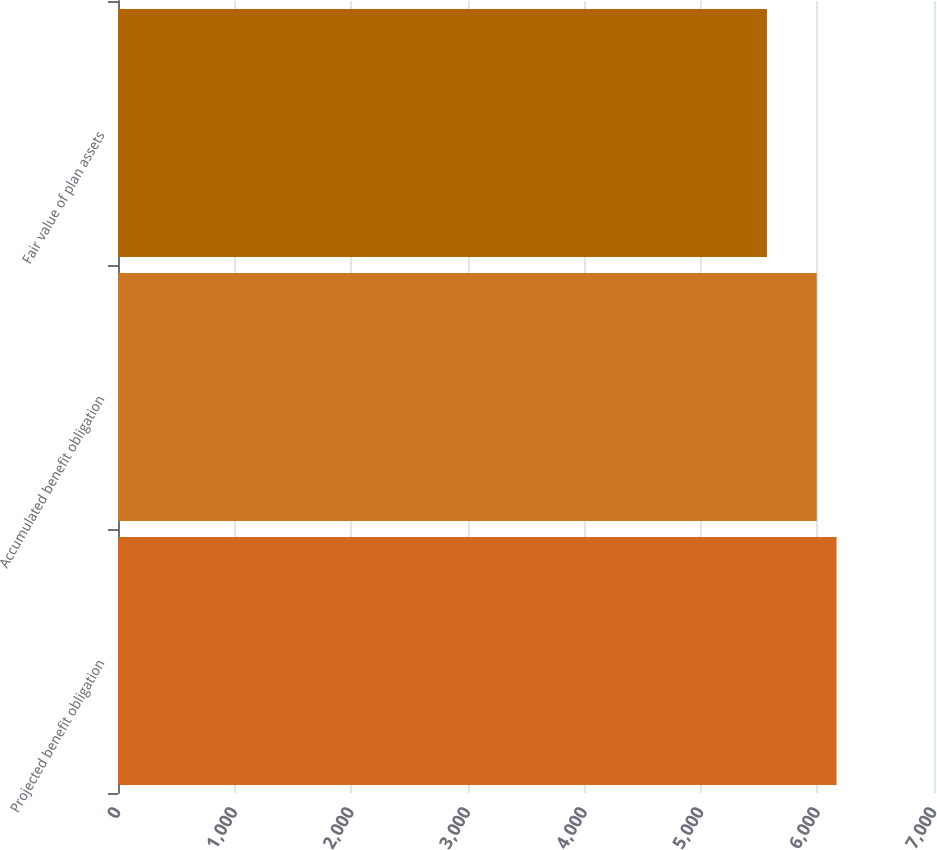Convert chart. <chart><loc_0><loc_0><loc_500><loc_500><bar_chart><fcel>Projected benefit obligation<fcel>Accumulated benefit obligation<fcel>Fair value of plan assets<nl><fcel>6164<fcel>5994<fcel>5567<nl></chart> 